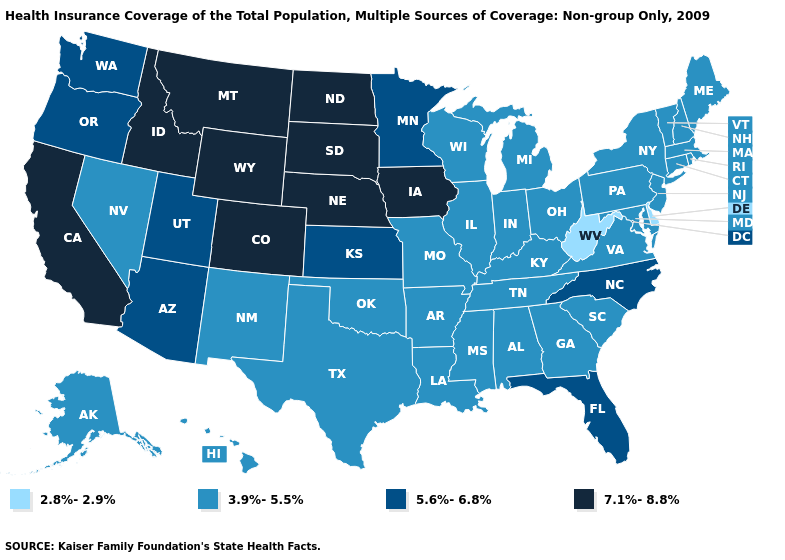Name the states that have a value in the range 3.9%-5.5%?
Concise answer only. Alabama, Alaska, Arkansas, Connecticut, Georgia, Hawaii, Illinois, Indiana, Kentucky, Louisiana, Maine, Maryland, Massachusetts, Michigan, Mississippi, Missouri, Nevada, New Hampshire, New Jersey, New Mexico, New York, Ohio, Oklahoma, Pennsylvania, Rhode Island, South Carolina, Tennessee, Texas, Vermont, Virginia, Wisconsin. Among the states that border Pennsylvania , does West Virginia have the highest value?
Keep it brief. No. What is the highest value in states that border Ohio?
Give a very brief answer. 3.9%-5.5%. Does South Dakota have the highest value in the USA?
Answer briefly. Yes. Does Pennsylvania have the lowest value in the USA?
Write a very short answer. No. Name the states that have a value in the range 2.8%-2.9%?
Short answer required. Delaware, West Virginia. Does Virginia have the same value as Alaska?
Keep it brief. Yes. Among the states that border Kentucky , which have the lowest value?
Answer briefly. West Virginia. Which states have the lowest value in the Northeast?
Give a very brief answer. Connecticut, Maine, Massachusetts, New Hampshire, New Jersey, New York, Pennsylvania, Rhode Island, Vermont. How many symbols are there in the legend?
Give a very brief answer. 4. Among the states that border Iowa , does Wisconsin have the highest value?
Be succinct. No. Name the states that have a value in the range 3.9%-5.5%?
Give a very brief answer. Alabama, Alaska, Arkansas, Connecticut, Georgia, Hawaii, Illinois, Indiana, Kentucky, Louisiana, Maine, Maryland, Massachusetts, Michigan, Mississippi, Missouri, Nevada, New Hampshire, New Jersey, New Mexico, New York, Ohio, Oklahoma, Pennsylvania, Rhode Island, South Carolina, Tennessee, Texas, Vermont, Virginia, Wisconsin. Does New Hampshire have the lowest value in the USA?
Be succinct. No. Name the states that have a value in the range 2.8%-2.9%?
Write a very short answer. Delaware, West Virginia. Name the states that have a value in the range 7.1%-8.8%?
Give a very brief answer. California, Colorado, Idaho, Iowa, Montana, Nebraska, North Dakota, South Dakota, Wyoming. 